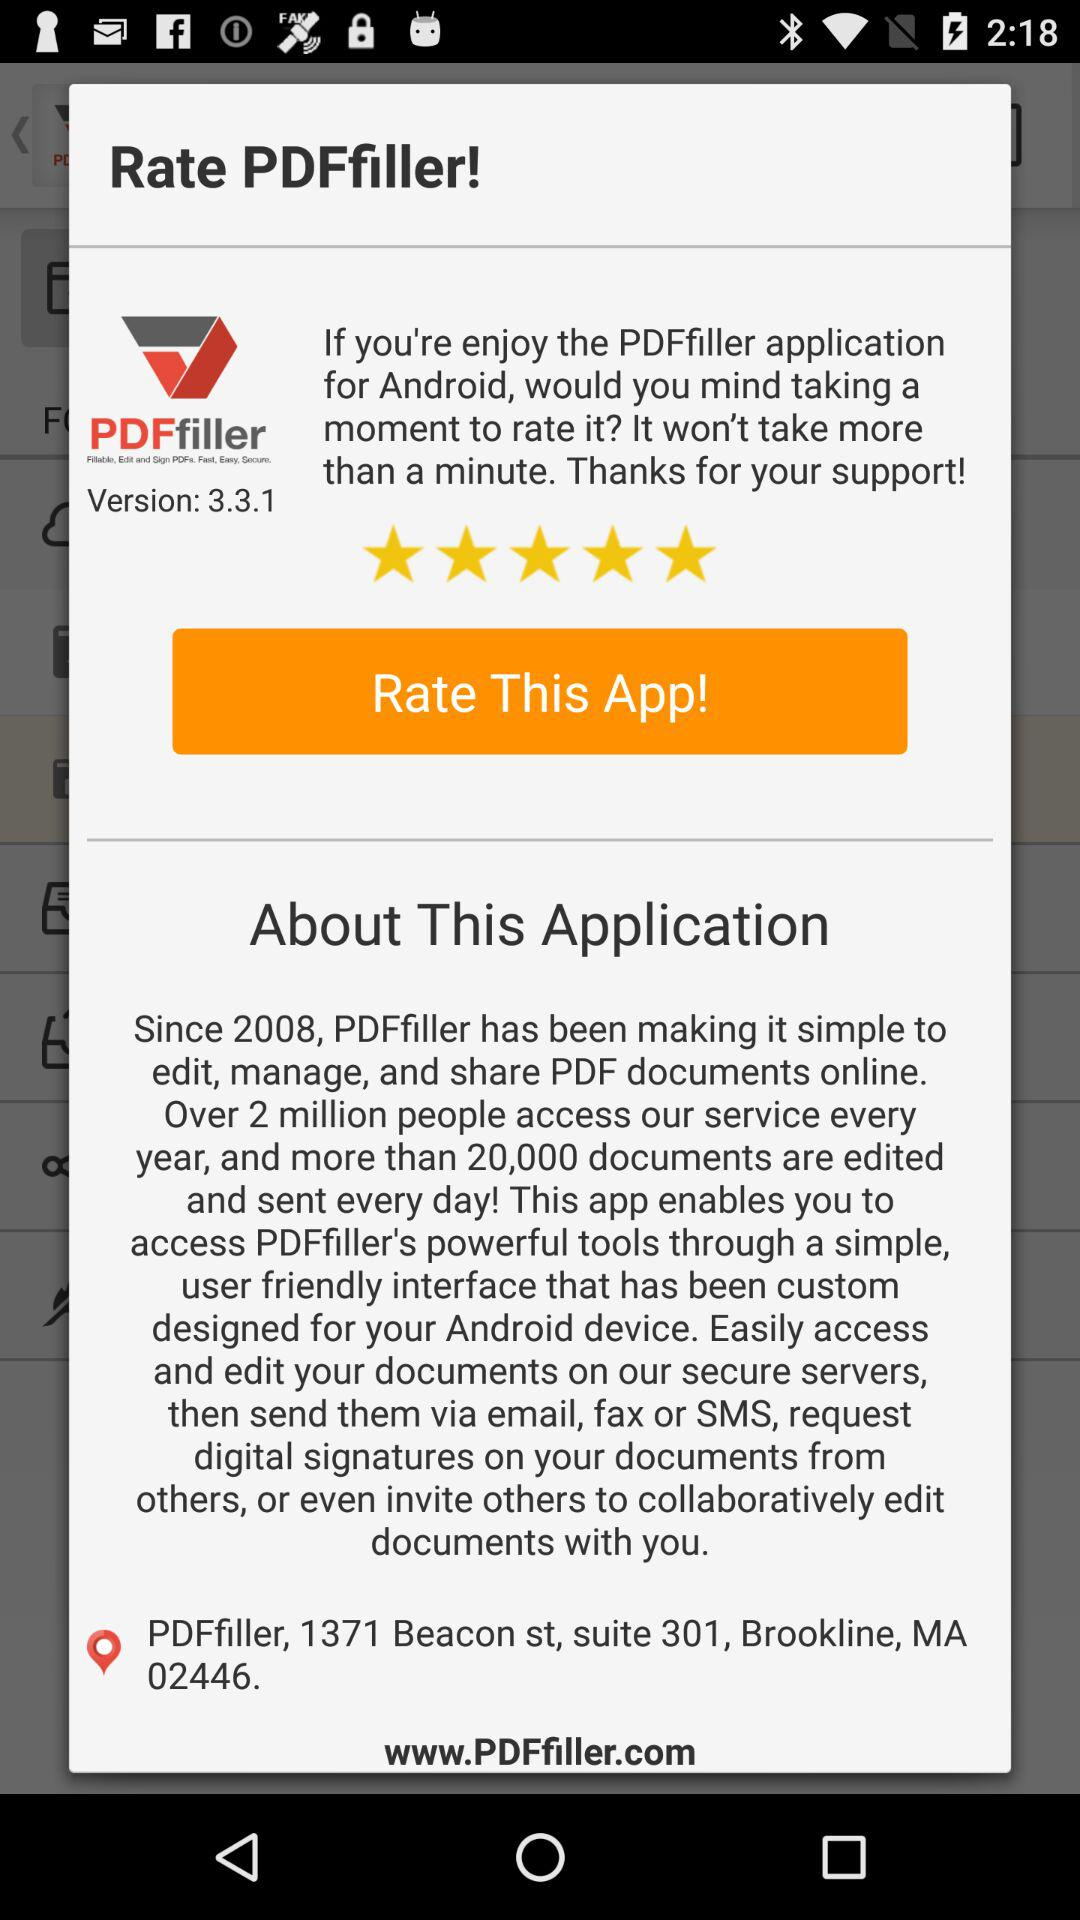What is the name of the application? The name of the application is "PDFfiller". 